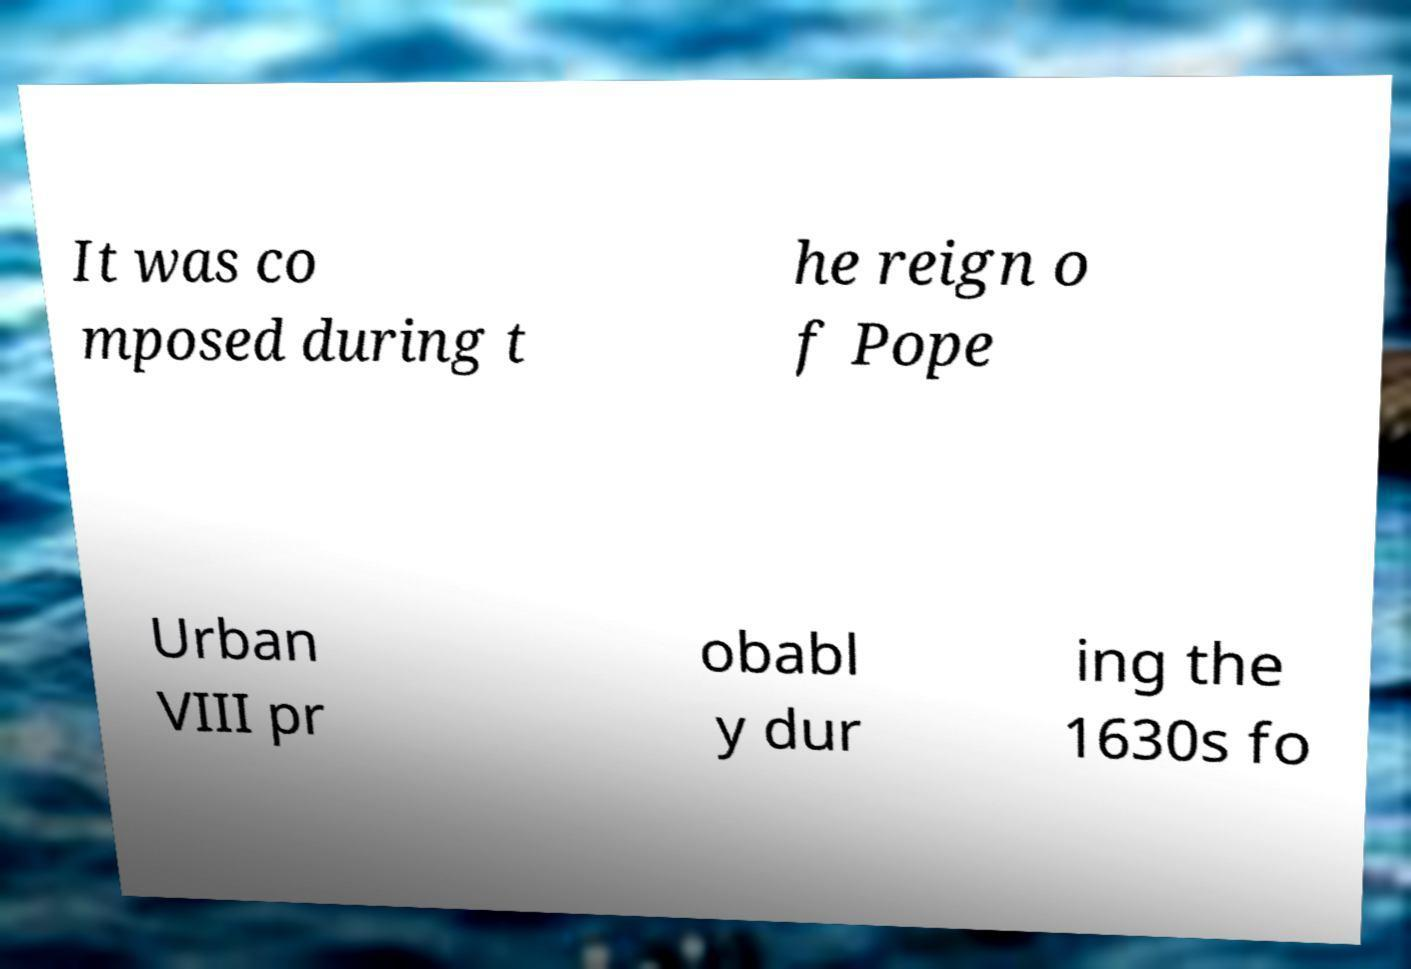I need the written content from this picture converted into text. Can you do that? It was co mposed during t he reign o f Pope Urban VIII pr obabl y dur ing the 1630s fo 